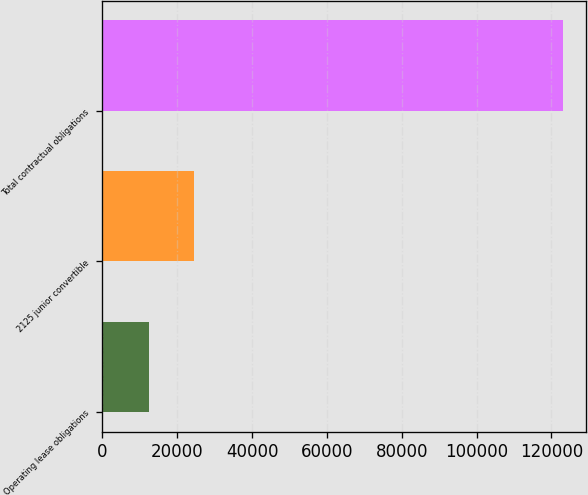Convert chart to OTSL. <chart><loc_0><loc_0><loc_500><loc_500><bar_chart><fcel>Operating lease obligations<fcel>2125 junior convertible<fcel>Total contractual obligations<nl><fcel>12415<fcel>24438<fcel>123003<nl></chart> 